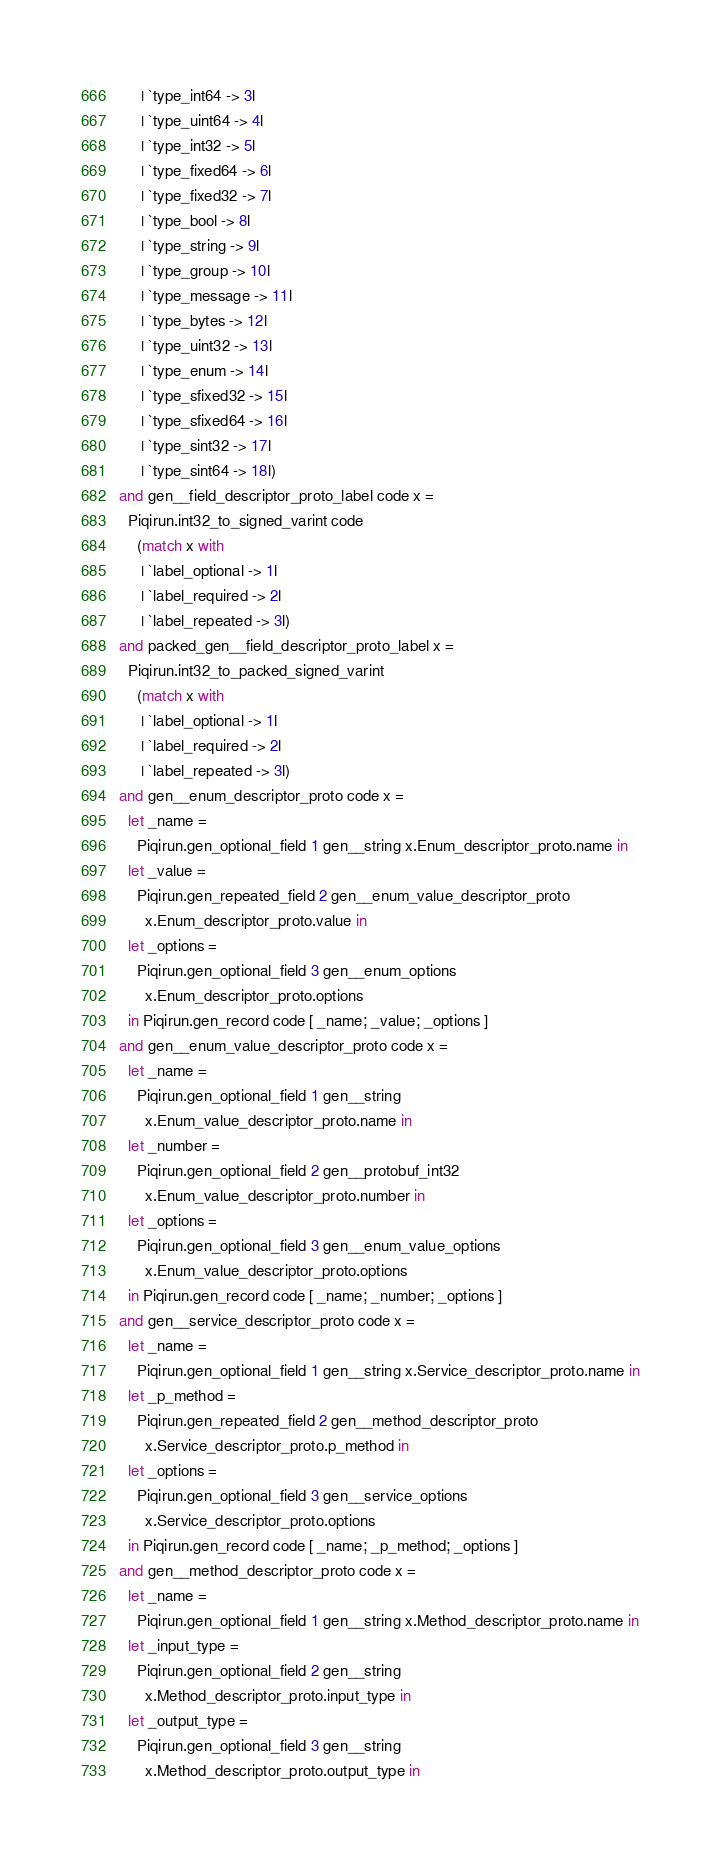Convert code to text. <code><loc_0><loc_0><loc_500><loc_500><_OCaml_>     | `type_int64 -> 3l
     | `type_uint64 -> 4l
     | `type_int32 -> 5l
     | `type_fixed64 -> 6l
     | `type_fixed32 -> 7l
     | `type_bool -> 8l
     | `type_string -> 9l
     | `type_group -> 10l
     | `type_message -> 11l
     | `type_bytes -> 12l
     | `type_uint32 -> 13l
     | `type_enum -> 14l
     | `type_sfixed32 -> 15l
     | `type_sfixed64 -> 16l
     | `type_sint32 -> 17l
     | `type_sint64 -> 18l)
and gen__field_descriptor_proto_label code x =
  Piqirun.int32_to_signed_varint code
    (match x with
     | `label_optional -> 1l
     | `label_required -> 2l
     | `label_repeated -> 3l)
and packed_gen__field_descriptor_proto_label x =
  Piqirun.int32_to_packed_signed_varint
    (match x with
     | `label_optional -> 1l
     | `label_required -> 2l
     | `label_repeated -> 3l)
and gen__enum_descriptor_proto code x =
  let _name =
    Piqirun.gen_optional_field 1 gen__string x.Enum_descriptor_proto.name in
  let _value =
    Piqirun.gen_repeated_field 2 gen__enum_value_descriptor_proto
      x.Enum_descriptor_proto.value in
  let _options =
    Piqirun.gen_optional_field 3 gen__enum_options
      x.Enum_descriptor_proto.options
  in Piqirun.gen_record code [ _name; _value; _options ]
and gen__enum_value_descriptor_proto code x =
  let _name =
    Piqirun.gen_optional_field 1 gen__string
      x.Enum_value_descriptor_proto.name in
  let _number =
    Piqirun.gen_optional_field 2 gen__protobuf_int32
      x.Enum_value_descriptor_proto.number in
  let _options =
    Piqirun.gen_optional_field 3 gen__enum_value_options
      x.Enum_value_descriptor_proto.options
  in Piqirun.gen_record code [ _name; _number; _options ]
and gen__service_descriptor_proto code x =
  let _name =
    Piqirun.gen_optional_field 1 gen__string x.Service_descriptor_proto.name in
  let _p_method =
    Piqirun.gen_repeated_field 2 gen__method_descriptor_proto
      x.Service_descriptor_proto.p_method in
  let _options =
    Piqirun.gen_optional_field 3 gen__service_options
      x.Service_descriptor_proto.options
  in Piqirun.gen_record code [ _name; _p_method; _options ]
and gen__method_descriptor_proto code x =
  let _name =
    Piqirun.gen_optional_field 1 gen__string x.Method_descriptor_proto.name in
  let _input_type =
    Piqirun.gen_optional_field 2 gen__string
      x.Method_descriptor_proto.input_type in
  let _output_type =
    Piqirun.gen_optional_field 3 gen__string
      x.Method_descriptor_proto.output_type in</code> 